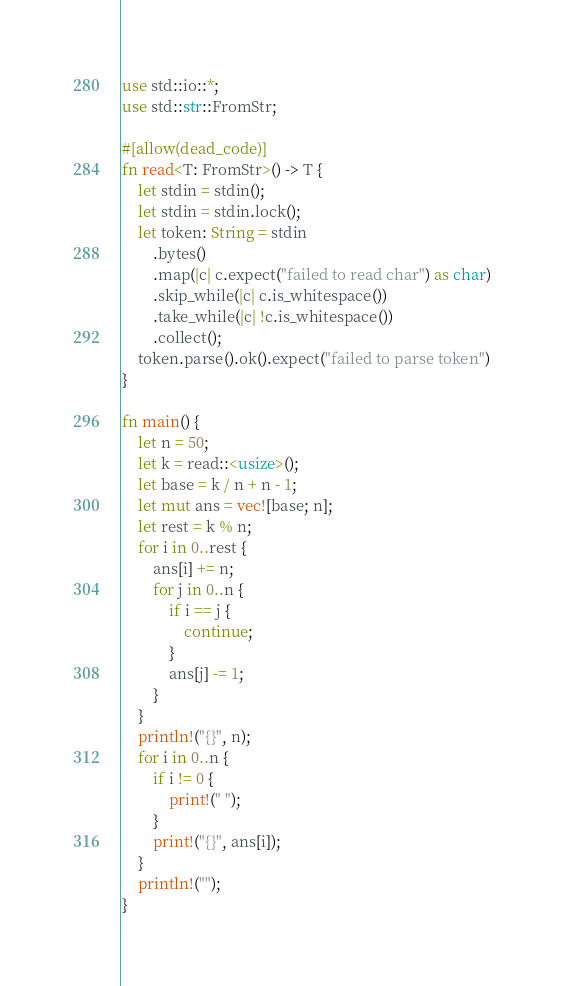<code> <loc_0><loc_0><loc_500><loc_500><_Rust_>use std::io::*;
use std::str::FromStr;

#[allow(dead_code)]
fn read<T: FromStr>() -> T {
    let stdin = stdin();
    let stdin = stdin.lock();
    let token: String = stdin
        .bytes()
        .map(|c| c.expect("failed to read char") as char)
        .skip_while(|c| c.is_whitespace())
        .take_while(|c| !c.is_whitespace())
        .collect();
    token.parse().ok().expect("failed to parse token")
}

fn main() {
    let n = 50;
    let k = read::<usize>();
    let base = k / n + n - 1;
    let mut ans = vec![base; n];
    let rest = k % n;
    for i in 0..rest {
        ans[i] += n;
        for j in 0..n {
            if i == j {
                continue;
            }
            ans[j] -= 1;
        }
    }
    println!("{}", n);
    for i in 0..n {
        if i != 0 {
            print!(" ");
        }
        print!("{}", ans[i]);
    }
    println!("");
}
</code> 